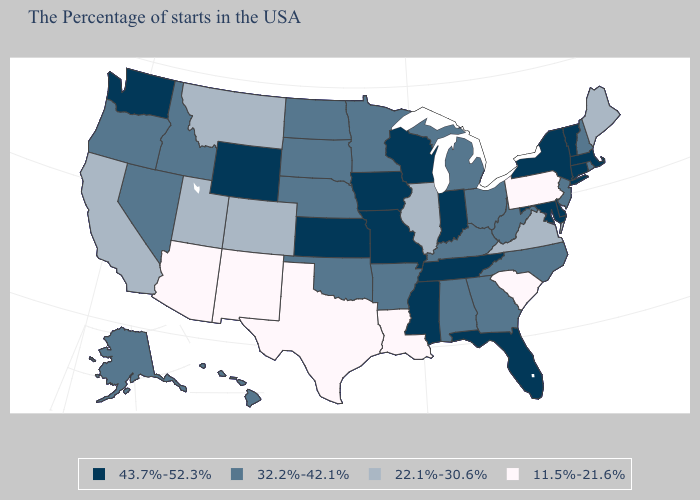Does the first symbol in the legend represent the smallest category?
Keep it brief. No. What is the value of Delaware?
Short answer required. 43.7%-52.3%. Among the states that border Illinois , which have the lowest value?
Write a very short answer. Kentucky. What is the value of Ohio?
Keep it brief. 32.2%-42.1%. What is the value of Florida?
Answer briefly. 43.7%-52.3%. Name the states that have a value in the range 43.7%-52.3%?
Short answer required. Massachusetts, Vermont, Connecticut, New York, Delaware, Maryland, Florida, Indiana, Tennessee, Wisconsin, Mississippi, Missouri, Iowa, Kansas, Wyoming, Washington. What is the value of Georgia?
Concise answer only. 32.2%-42.1%. What is the value of Connecticut?
Short answer required. 43.7%-52.3%. Which states have the lowest value in the USA?
Concise answer only. Pennsylvania, South Carolina, Louisiana, Texas, New Mexico, Arizona. What is the lowest value in the USA?
Short answer required. 11.5%-21.6%. What is the value of Iowa?
Write a very short answer. 43.7%-52.3%. What is the highest value in the West ?
Keep it brief. 43.7%-52.3%. What is the value of Arkansas?
Concise answer only. 32.2%-42.1%. What is the value of New York?
Give a very brief answer. 43.7%-52.3%. Among the states that border Delaware , which have the lowest value?
Give a very brief answer. Pennsylvania. 